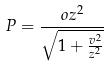<formula> <loc_0><loc_0><loc_500><loc_500>P = \frac { o z ^ { 2 } } { \sqrt { 1 + \frac { v ^ { 2 } } { z ^ { 2 } } } }</formula> 